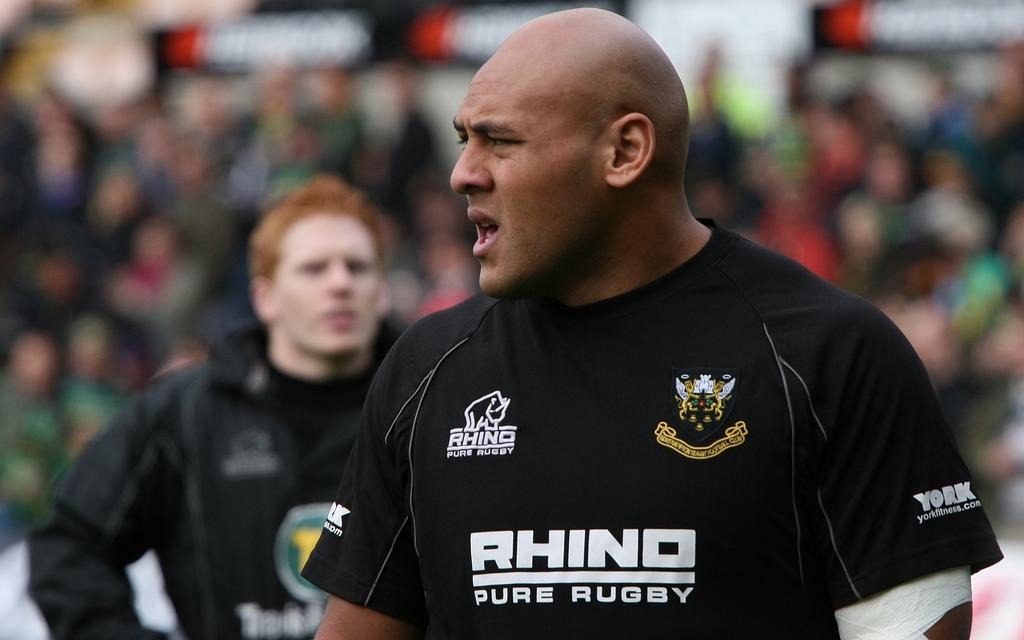<image>
Present a compact description of the photo's key features. A bald man wears a shirt that says "rhino pure rugby." 